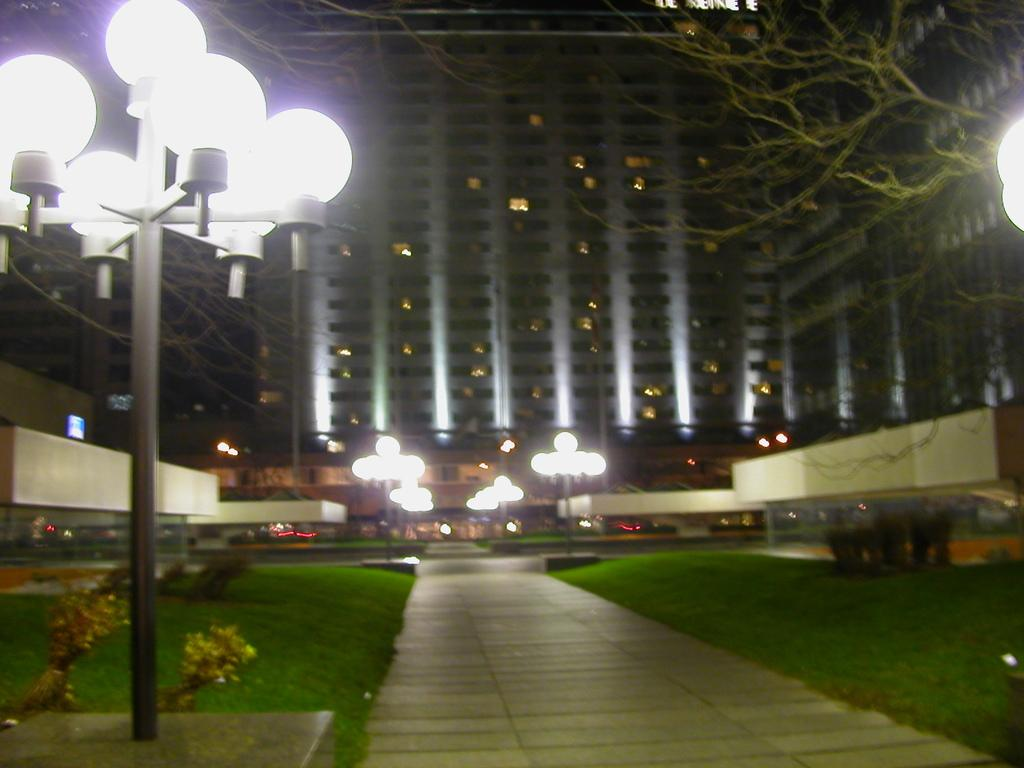What type of lighting is present on the left side of the image? There are white color lights on the left side of the image. What is the main structure in the middle of the image? There is a very big building in the middle of the image. What type of vegetation is on the right side of the image? There is a green color tree on the right side of the image. How many cars are parked under the tree on the right side of the image? There are no cars present in the image; it features a green color tree. What type of ornament is hanging from the tree in the image? There is no ornament hanging from the tree in the image; only the tree is present. 